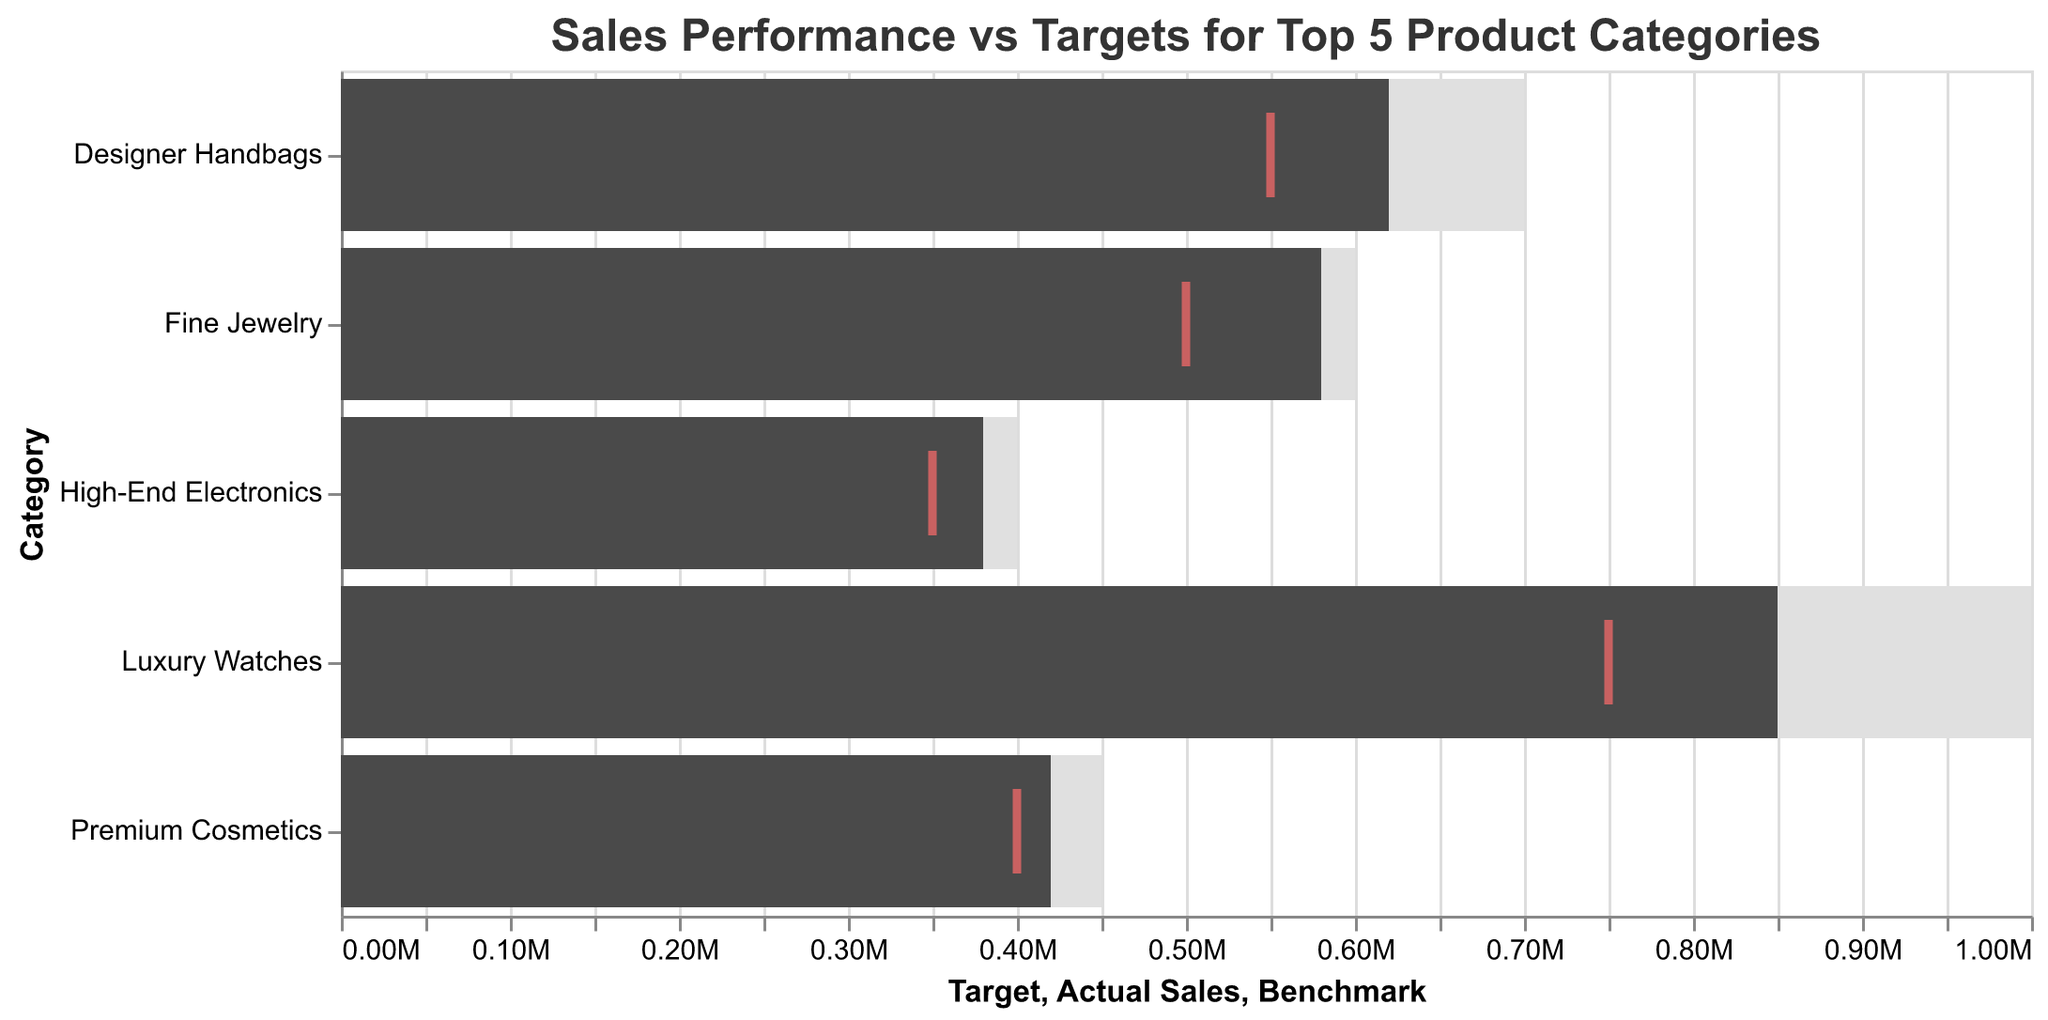What's the title of the figure? The title is usually located at the top of the chart and provides a brief description of what the chart represents.
Answer: Sales Performance vs Targets for Top 5 Product Categories How many product categories are shown in the chart? Each bar represents a product category, and the chart shows all the top 5 product categories as listed in the dataset.
Answer: 5 What does the tick mark indicate in the chart? The tick mark often represents a benchmark value for each category, providing a visual reference for comparison against actual sales and targets.
Answer: Benchmark value What color is used to represent actual sales? The color used to represent actual sales is typically distinguishable and is darker compared to the background bars representing targets.
Answer: Dark gray Which product category has the highest actual sales? By observing the lengths of the dark gray bars, the category with the longest bar represents the highest actual sales.
Answer: Luxury Watches Which product category came closest to meeting its target? Compare the length of the dark gray bar (actual sales) to the light gray bar (target) for each category to find the closest match.
Answer: Fine Jewelry What is the difference between actual sales and the target for Luxury Watches? Subtract the actual sales value from the target value for the Luxury Watches category. (1000000 - 850000)
Answer: 150000 Are the actual sales of Designer Handbags higher than their benchmark? Compare the actual sales value (620000) to the benchmark value (550000) for Designer Handbags.
Answer: Yes What is the average actual sales across all product categories? Sum all the actual sales values (850000 + 620000 + 580000 + 420000 + 380000) and divide by the number of categories (5).
Answer: 570000 Which product category has the smallest gap between actual sales and benchmark? Subtract benchmark from actual sales for each category and identify the smallest difference.
Answer: Fine Jewelry How does the target of High-End Electronics compare to its benchmark? Compare the target value (400000) to the benchmark value (350000) for High-End Electronics.
Answer: Higher 